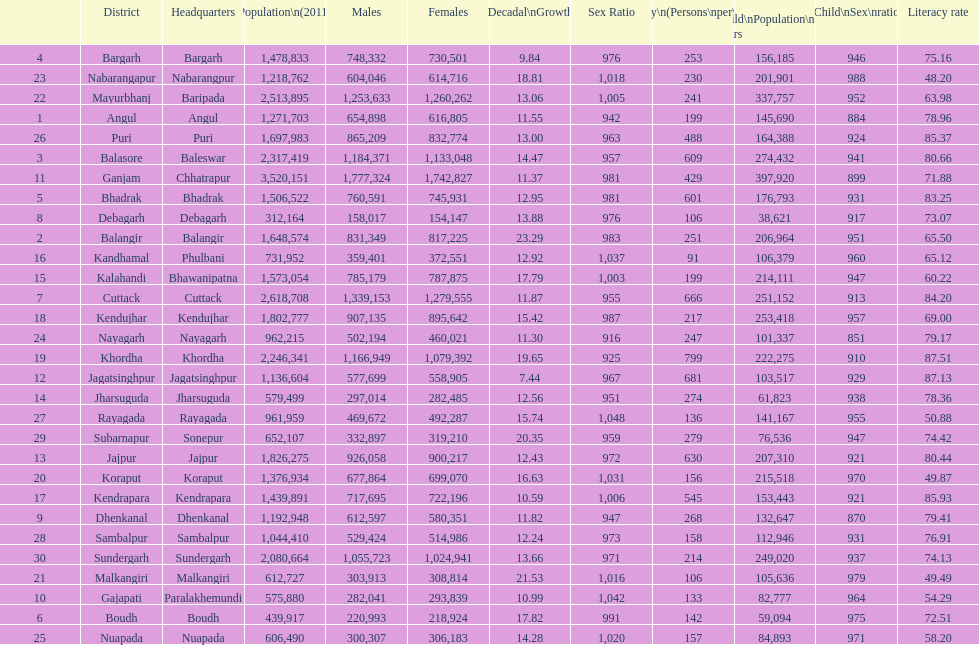Between angul and cuttack districts, which one has a greater population? Cuttack. 